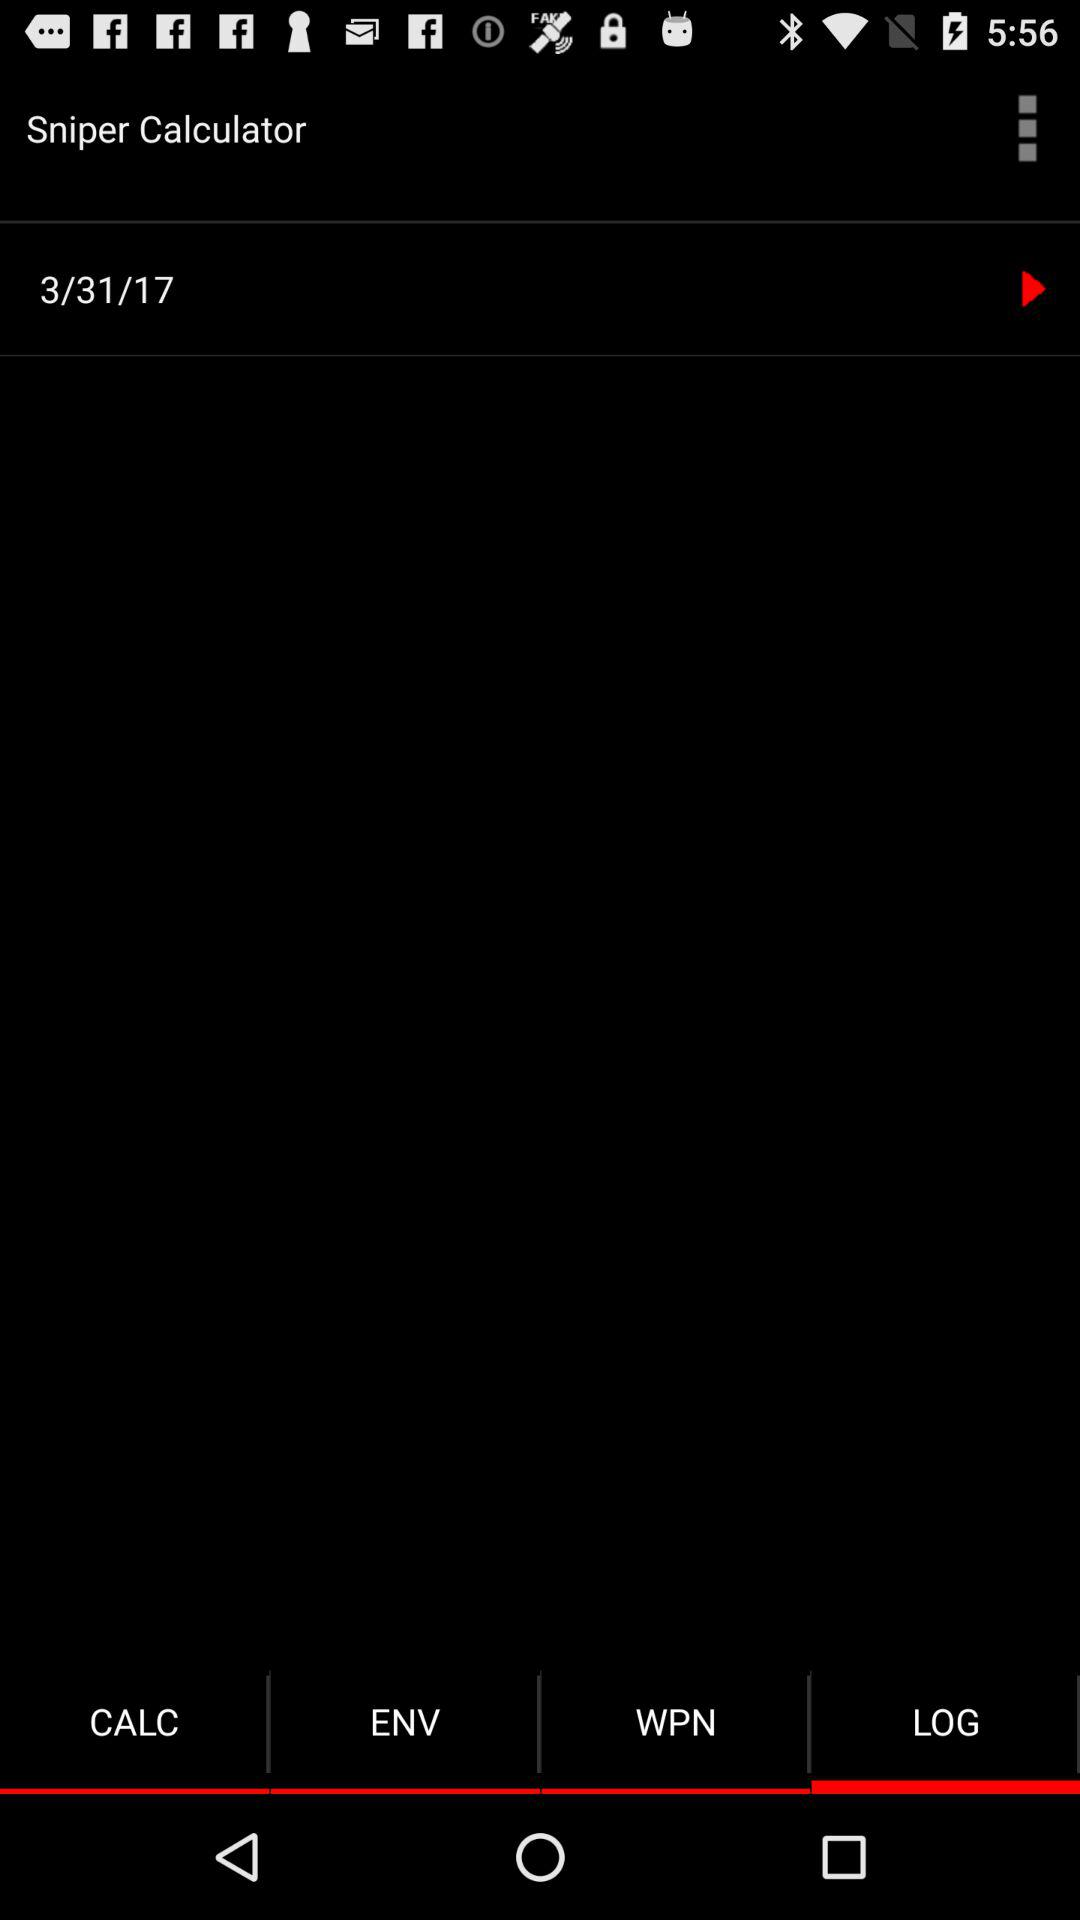Which tab is selected? The selected tab is "LOG". 